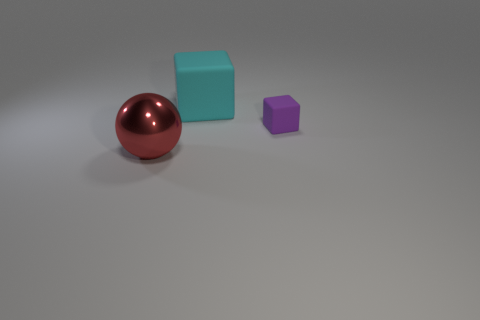Is there any other thing that is made of the same material as the red object?
Offer a terse response. No. Is there any other thing that has the same size as the purple cube?
Your answer should be very brief. No. There is a large block; are there any large metal objects behind it?
Keep it short and to the point. No. The big object right of the big thing on the left side of the big object right of the red shiny sphere is what color?
Your answer should be compact. Cyan. How many things are both right of the big sphere and in front of the big cyan cube?
Your answer should be very brief. 1. What number of cylinders are either large rubber things or metal things?
Give a very brief answer. 0. Are any small rubber blocks visible?
Provide a succinct answer. Yes. What number of other things are made of the same material as the large red thing?
Make the answer very short. 0. There is a cyan block that is the same size as the shiny sphere; what material is it?
Your response must be concise. Rubber. There is a big thing that is behind the big metal object; does it have the same shape as the large red shiny object?
Offer a terse response. No. 